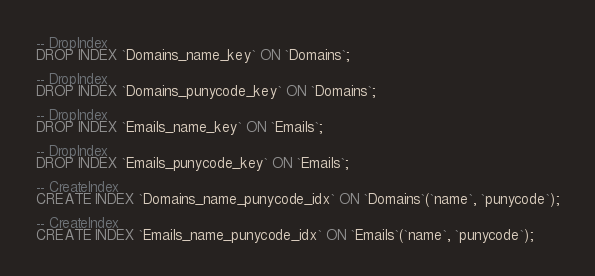<code> <loc_0><loc_0><loc_500><loc_500><_SQL_>-- DropIndex
DROP INDEX `Domains_name_key` ON `Domains`;

-- DropIndex
DROP INDEX `Domains_punycode_key` ON `Domains`;

-- DropIndex
DROP INDEX `Emails_name_key` ON `Emails`;

-- DropIndex
DROP INDEX `Emails_punycode_key` ON `Emails`;

-- CreateIndex
CREATE INDEX `Domains_name_punycode_idx` ON `Domains`(`name`, `punycode`);

-- CreateIndex
CREATE INDEX `Emails_name_punycode_idx` ON `Emails`(`name`, `punycode`);
</code> 